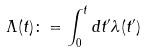Convert formula to latex. <formula><loc_0><loc_0><loc_500><loc_500>\Lambda ( t ) \colon = \int _ { 0 } ^ { t } d t ^ { \prime } \lambda ( t ^ { \prime } )</formula> 